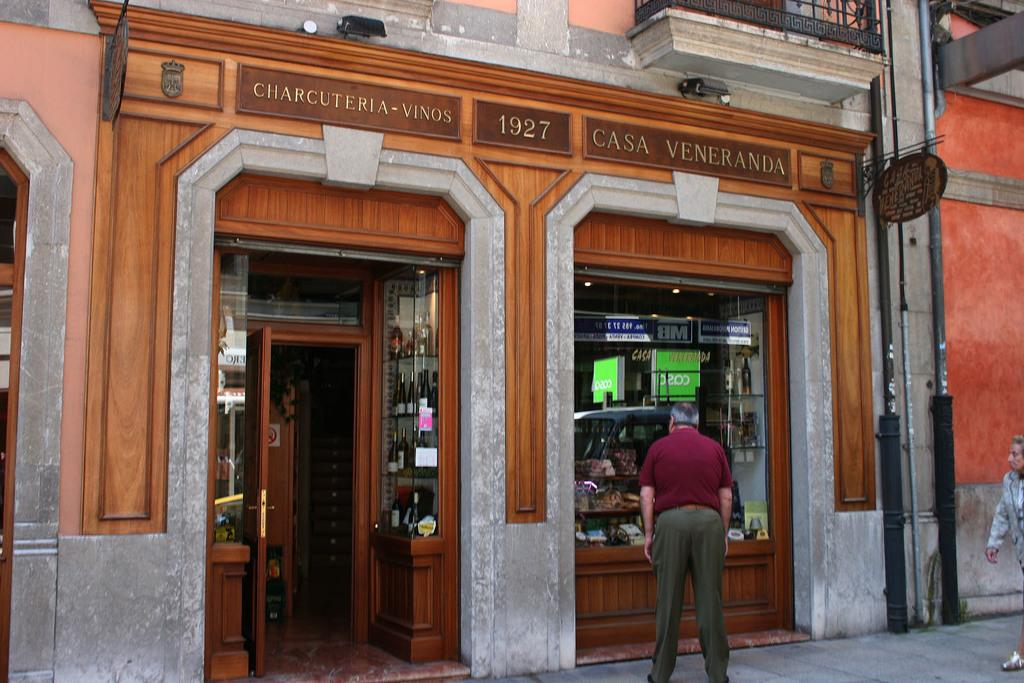<image>
Offer a succinct explanation of the picture presented. Person looking into  the window of a store called Casa Veneranda. 